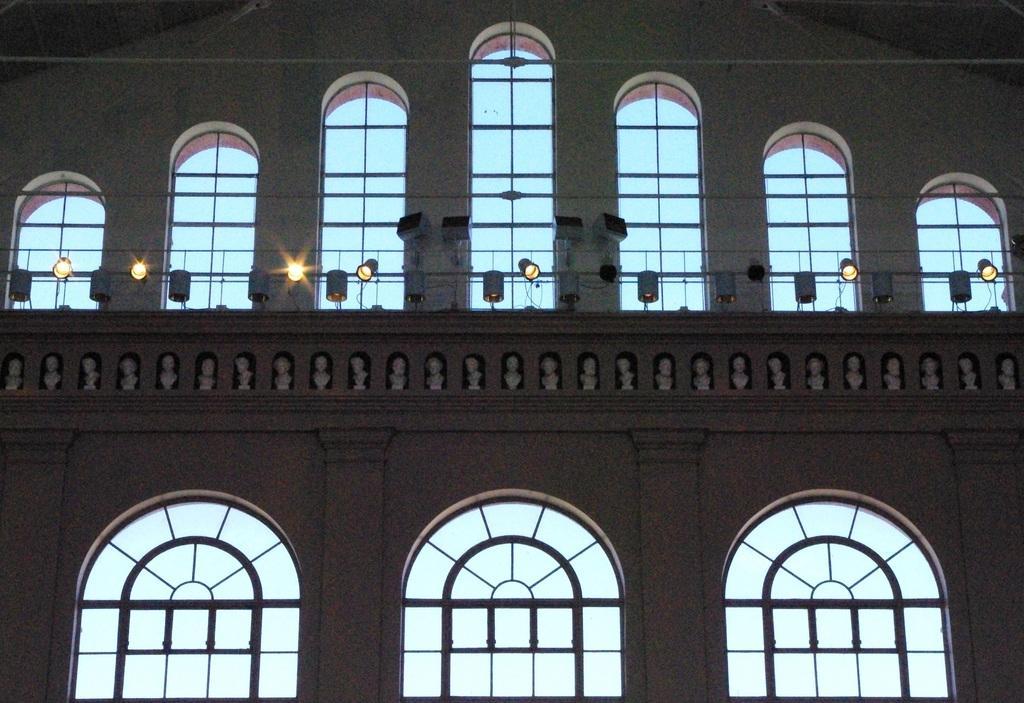How would you summarize this image in a sentence or two? In this picture we can see a few rods, pillars, arches and dome lights. This is an inside view of a building. 